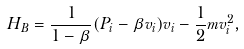<formula> <loc_0><loc_0><loc_500><loc_500>H _ { B } = \frac { 1 } { 1 - \beta } ( P _ { i } - \beta v _ { i } ) v _ { i } - \frac { 1 } { 2 } m v _ { i } ^ { 2 } ,</formula> 